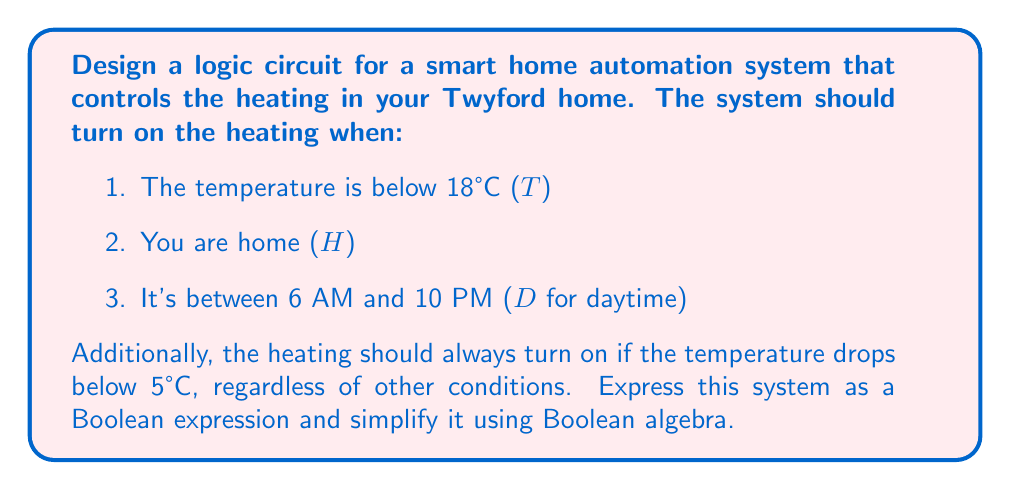Show me your answer to this math problem. Let's approach this step-by-step:

1) First, we'll write out the Boolean expression based on the given conditions:

   $$(T \cdot H \cdot D) + T_{5°C}$$

   Where $T_{5°C}$ represents the temperature being below 5°C.

2) We can expand this expression:

   $$T \cdot H \cdot D + T_{5°C}$$

3) This expression is already in its simplest form as a sum of products. However, we can make an observation:

   If the temperature is below 5°C ($T_{5°C}$ is true), it's also below 18°C (T is true).

4) This means $T_{5°C}$ implies T, or in Boolean algebra terms:

   $$T_{5°C} \rightarrow T$$
   $$T_{5°C} + T = T$$

5) Using this, we can rewrite our expression:

   $$T \cdot (H \cdot D + T_{5°C})$$

6) This is the simplified Boolean expression for the heating control system.

To implement this as a logic circuit:
- Use AND gates for the products (·)
- Use OR gates for the sums (+)
- The inputs would be T, H, D, and $T_{5°C}$
- The output would be the heating control signal
Answer: $$T \cdot (H \cdot D + T_{5°C})$$ 